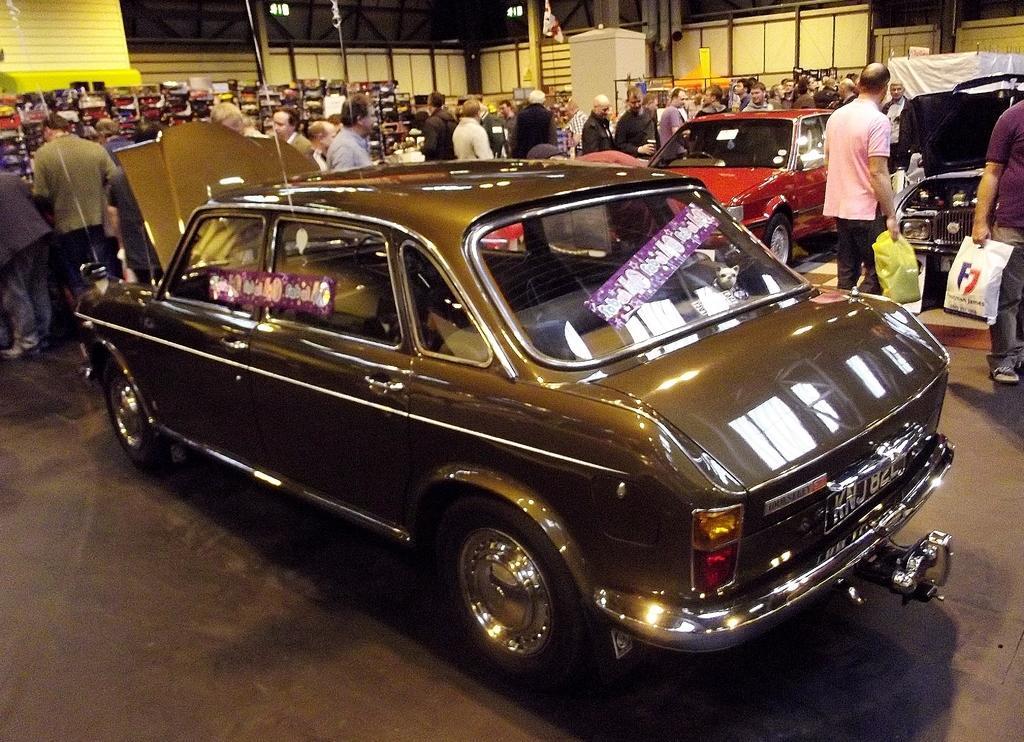Please provide a concise description of this image. In this image I can see the vehicles and many people with different color dresses. To the right I can see two people holding the plastic covers. In the background I can see few objects and the poles. 